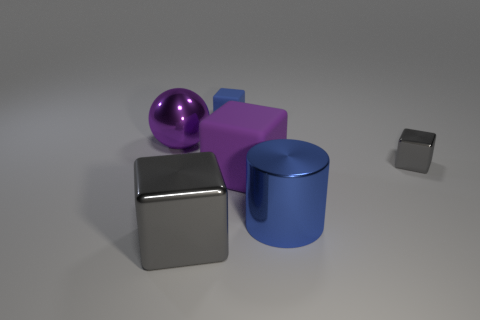What material is the object that is the same color as the large cylinder?
Provide a short and direct response. Rubber. What size is the shiny cylinder that is the same color as the small matte block?
Give a very brief answer. Large. Is the number of blue rubber blocks in front of the cylinder less than the number of big balls that are on the right side of the purple block?
Offer a terse response. No. Is the material of the tiny blue cube the same as the big purple cube that is in front of the small gray shiny thing?
Offer a very short reply. Yes. Is there any other thing that is made of the same material as the cylinder?
Offer a terse response. Yes. Is the number of tiny gray metallic cubes greater than the number of green shiny spheres?
Your answer should be very brief. Yes. The gray metallic object to the left of the gray metallic object that is on the right side of the big thing that is in front of the cylinder is what shape?
Keep it short and to the point. Cube. Is the material of the purple thing right of the tiny matte object the same as the thing behind the metallic sphere?
Your answer should be compact. Yes. What shape is the large blue object that is made of the same material as the large ball?
Your answer should be very brief. Cylinder. Is there any other thing that is the same color as the big metal cylinder?
Ensure brevity in your answer.  Yes. 